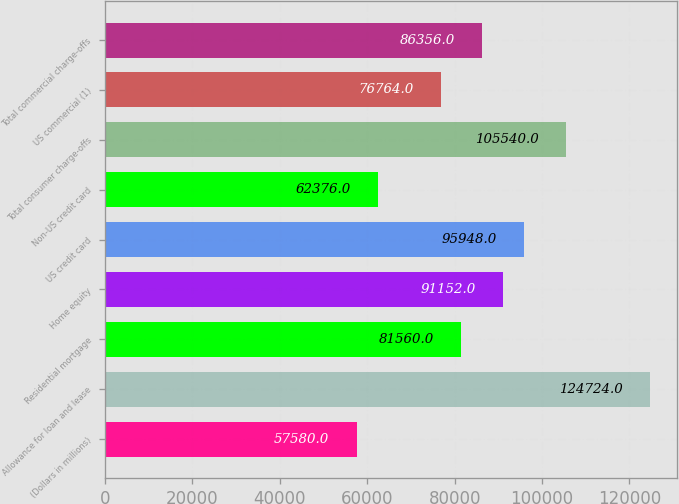Convert chart to OTSL. <chart><loc_0><loc_0><loc_500><loc_500><bar_chart><fcel>(Dollars in millions)<fcel>Allowance for loan and lease<fcel>Residential mortgage<fcel>Home equity<fcel>US credit card<fcel>Non-US credit card<fcel>Total consumer charge-offs<fcel>US commercial (1)<fcel>Total commercial charge-offs<nl><fcel>57580<fcel>124724<fcel>81560<fcel>91152<fcel>95948<fcel>62376<fcel>105540<fcel>76764<fcel>86356<nl></chart> 